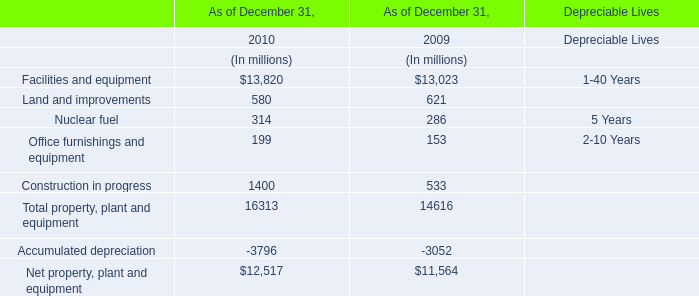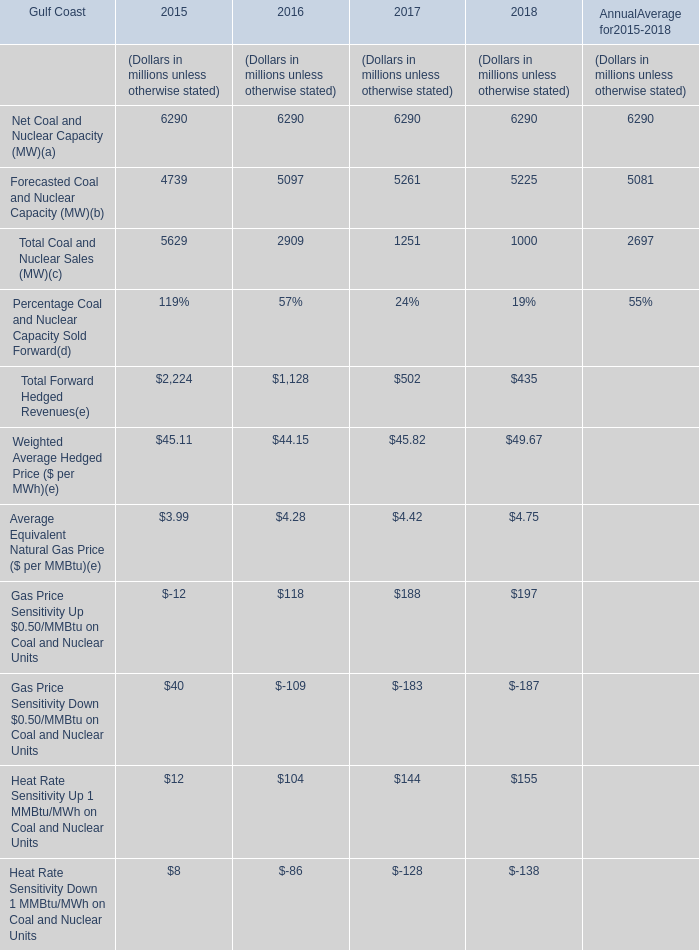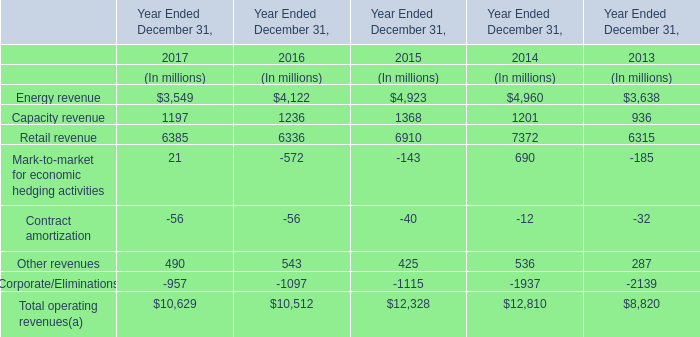Which year is Forecasted Coal and Nuclear Capacity (MW) the most? 
Answer: 2017. 